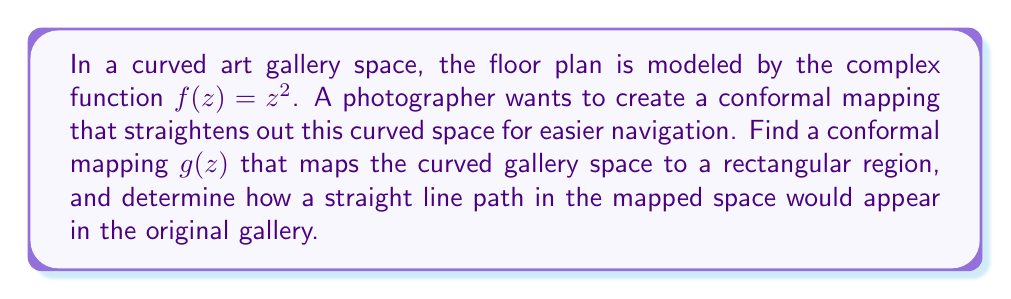Show me your answer to this math problem. To solve this problem, we'll follow these steps:

1) First, we need to find the inverse function of $f(z) = z^2$. This inverse function will be our conformal mapping $g(z)$.

   The inverse of $z^2$ is the square root function. However, we need to be careful about the branch cut. In complex analysis, we typically use the principal branch of the square root function.

   $g(z) = \sqrt{z} = z^{\frac{1}{2}}$

2) This function $g(z)$ maps the curved gallery space to a half-plane. To get a rectangular region, we can compose this with another conformal map, such as the logarithm function. However, for simplicity, we'll work with the half-plane mapping.

3) Now, let's consider how a straight line path in the mapped space (the half-plane) would appear in the original gallery space.

   In the mapped space, a straight line can be represented as:

   $w = a + bi$, where $a$ and $b$ are real constants and $i$ is the imaginary unit.

4) To see how this appears in the original space, we need to apply the inverse mapping $f(z) = z^2$:

   $z^2 = a + bi$

5) To visualize this, let's separate the real and imaginary parts. If we write $z = x + yi$, then:

   $(x + yi)^2 = a + bi$
   $x^2 - y^2 + 2xyi = a + bi$

6) Equating real and imaginary parts:

   $x^2 - y^2 = a$
   $2xy = b$

7) The equation $x^2 - y^2 = a$ represents a hyperbola in the xy-plane (our original gallery space). The equation $2xy = b$ represents another hyperbola.

8) The path in the original space is the intersection of these two hyperbolas.

Therefore, a straight line in the mapped space appears as a curved path (specifically, a hyperbola) in the original curved gallery space.
Answer: The conformal mapping that straightens the curved gallery space is $g(z) = \sqrt{z}$. A straight line path in the mapped space would appear as a hyperbola in the original curved gallery space, described by the intersection of the equations $x^2 - y^2 = a$ and $2xy = b$, where $a$ and $b$ are constants determined by the specific straight line in the mapped space. 